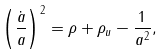<formula> <loc_0><loc_0><loc_500><loc_500>\left ( \frac { \dot { a } } { a } \right ) ^ { 2 } = \rho + \rho _ { u } - \frac { 1 } { a ^ { 2 } } ,</formula> 